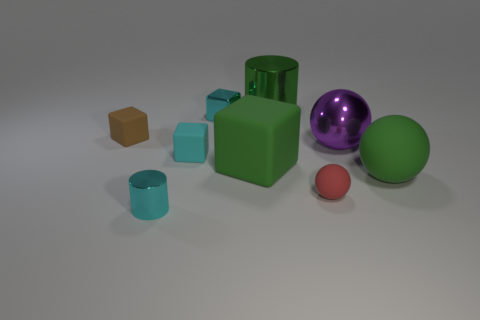What color is the cylinder that is behind the green rubber object left of the small red ball?
Ensure brevity in your answer.  Green. Is there a brown block?
Offer a very short reply. Yes. Does the small brown thing have the same shape as the red thing?
Provide a succinct answer. No. What is the size of the metal cylinder that is the same color as the large rubber block?
Your answer should be compact. Large. There is a cyan metallic thing behind the small red matte object; what number of rubber spheres are behind it?
Your response must be concise. 0. What number of green things are behind the tiny cyan matte block and in front of the big green metal cylinder?
Provide a short and direct response. 0. What number of things are tiny cylinders or big green objects that are on the left side of the red thing?
Your answer should be very brief. 3. There is a green thing that is made of the same material as the purple thing; what is its size?
Ensure brevity in your answer.  Large. There is a cyan thing in front of the large cube in front of the brown matte block; what is its shape?
Keep it short and to the point. Cylinder. How many cyan things are either tiny blocks or large matte objects?
Give a very brief answer. 2. 